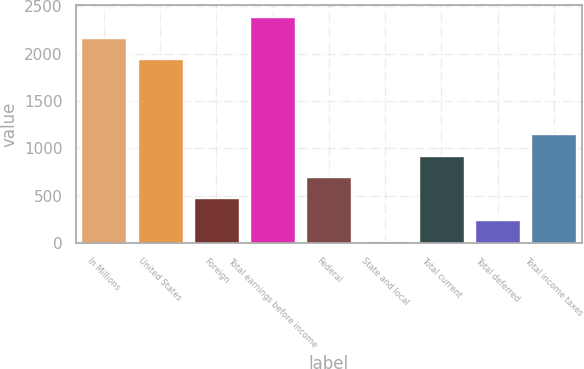<chart> <loc_0><loc_0><loc_500><loc_500><bar_chart><fcel>In Millions<fcel>United States<fcel>Foreign<fcel>Total earnings before income<fcel>Federal<fcel>State and local<fcel>Total current<fcel>Total deferred<fcel>Total income taxes<nl><fcel>2166.62<fcel>1941.6<fcel>471.14<fcel>2391.64<fcel>696.16<fcel>21.1<fcel>921.18<fcel>246.12<fcel>1146.2<nl></chart> 